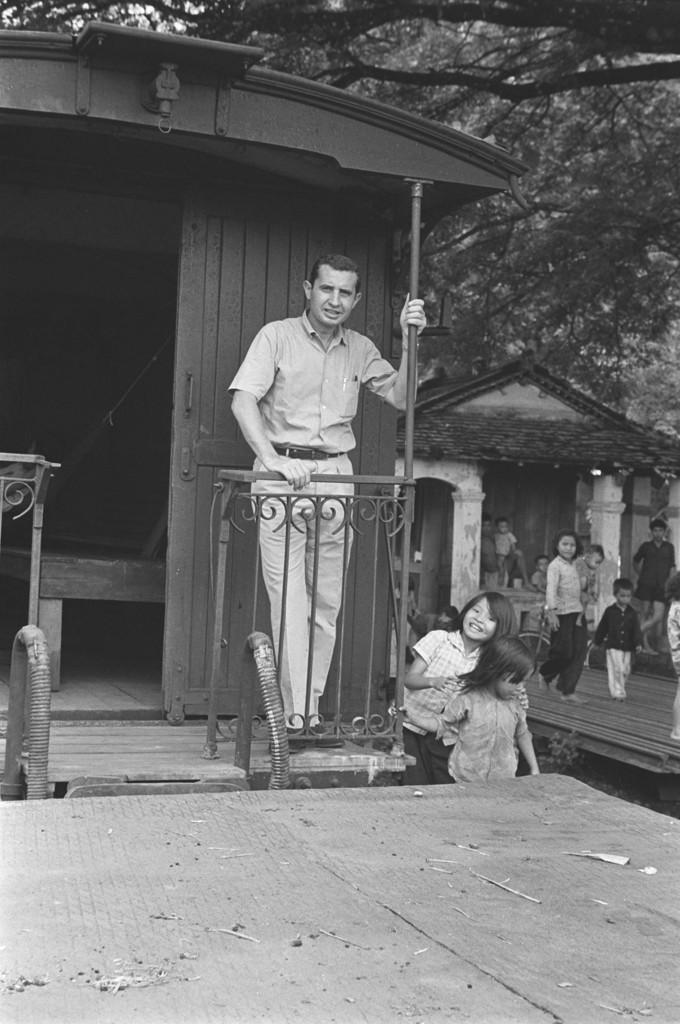What is the main subject in the image? There is a person standing beside the house in the image. Can you describe the people in the image? There is a person standing beside the house, and there are children behind the person. What type of structure is visible in the image? There is a house with a roof and pillars visible in the image. What type of vegetation is present in the image? Trees are present in the image. What type of potato is being harvested in the image? There is no potato or harvesting activity present in the image. What season is depicted in the image? The provided facts do not give any information about the season, so it cannot be determined from the image. 